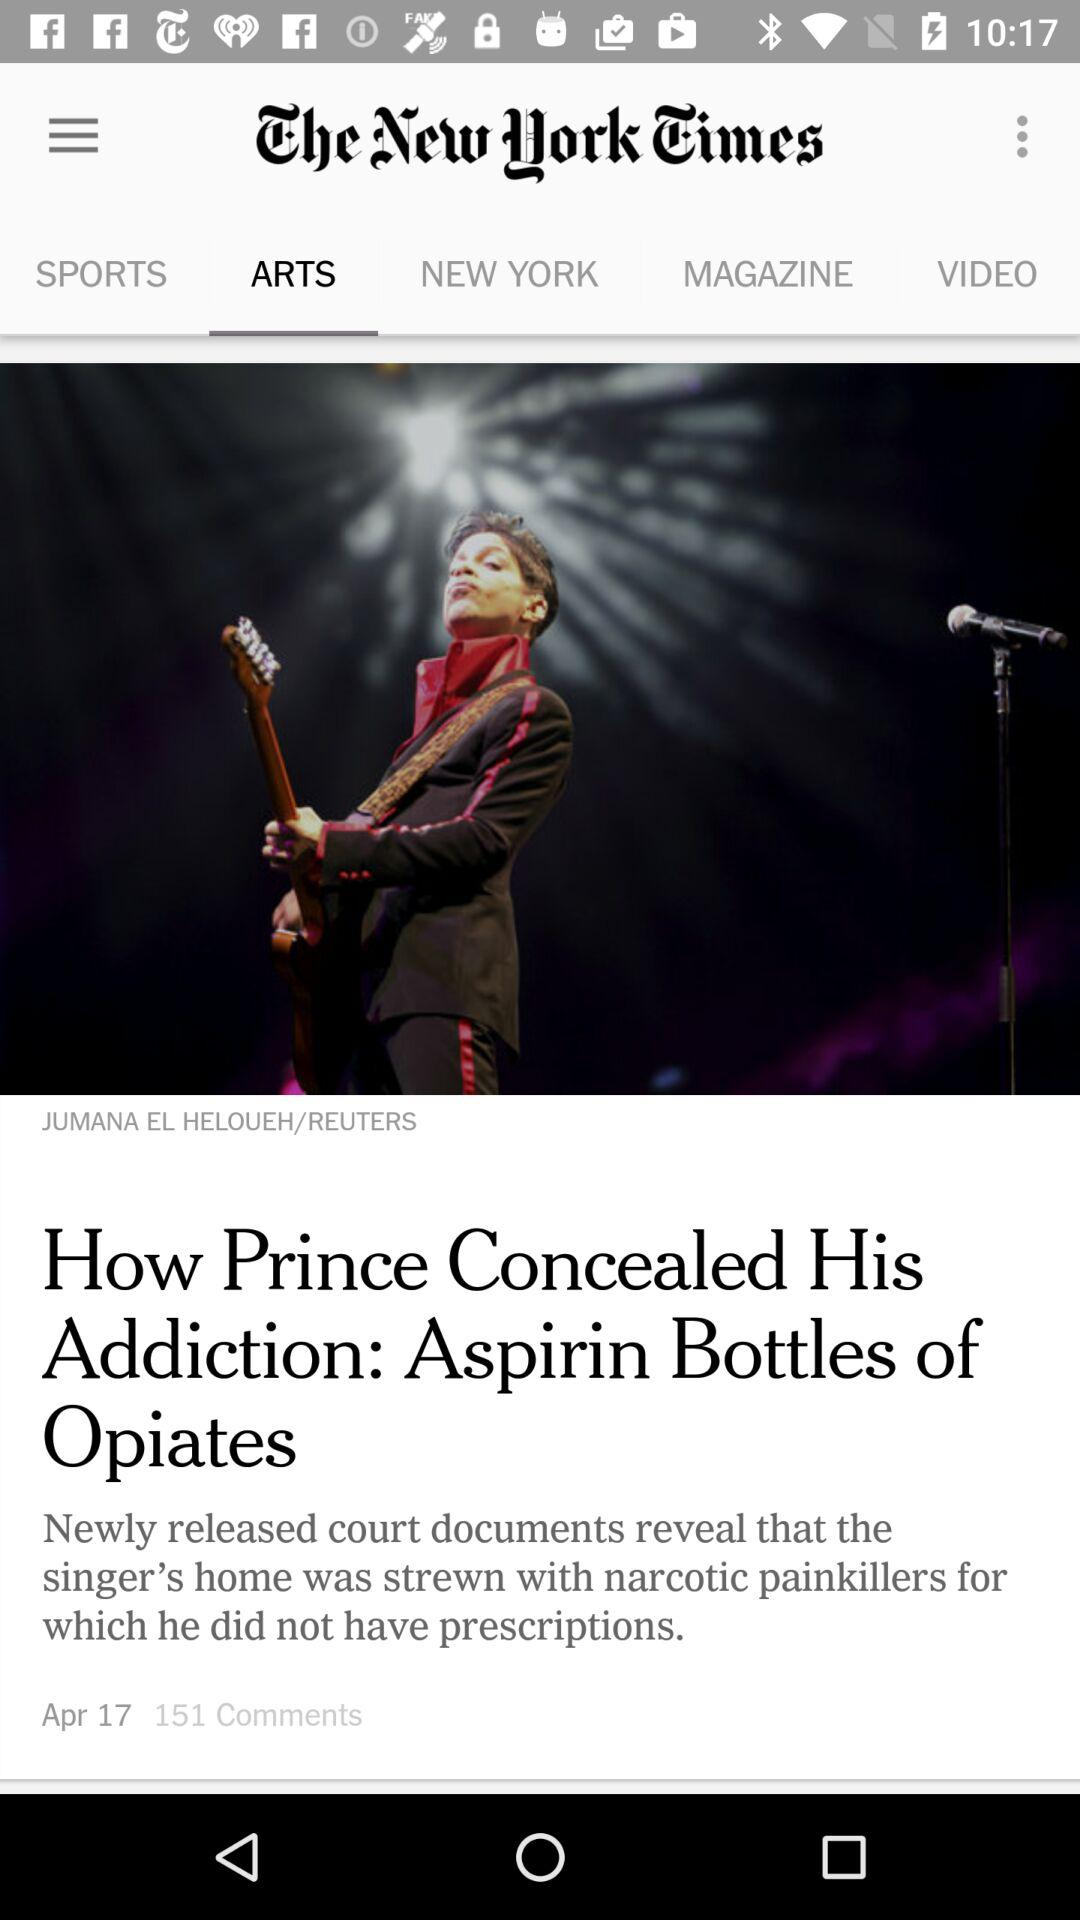Which tab am I now on? You are now on the "ARTS" tab. 